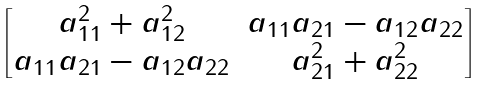<formula> <loc_0><loc_0><loc_500><loc_500>\begin{bmatrix} a _ { 1 1 } ^ { 2 } + a _ { 1 2 } ^ { 2 } & a _ { 1 1 } a _ { 2 1 } - a _ { 1 2 } a _ { 2 2 } \\ a _ { 1 1 } a _ { 2 1 } - a _ { 1 2 } a _ { 2 2 } & a _ { 2 1 } ^ { 2 } + a _ { 2 2 } ^ { 2 } \end{bmatrix}</formula> 